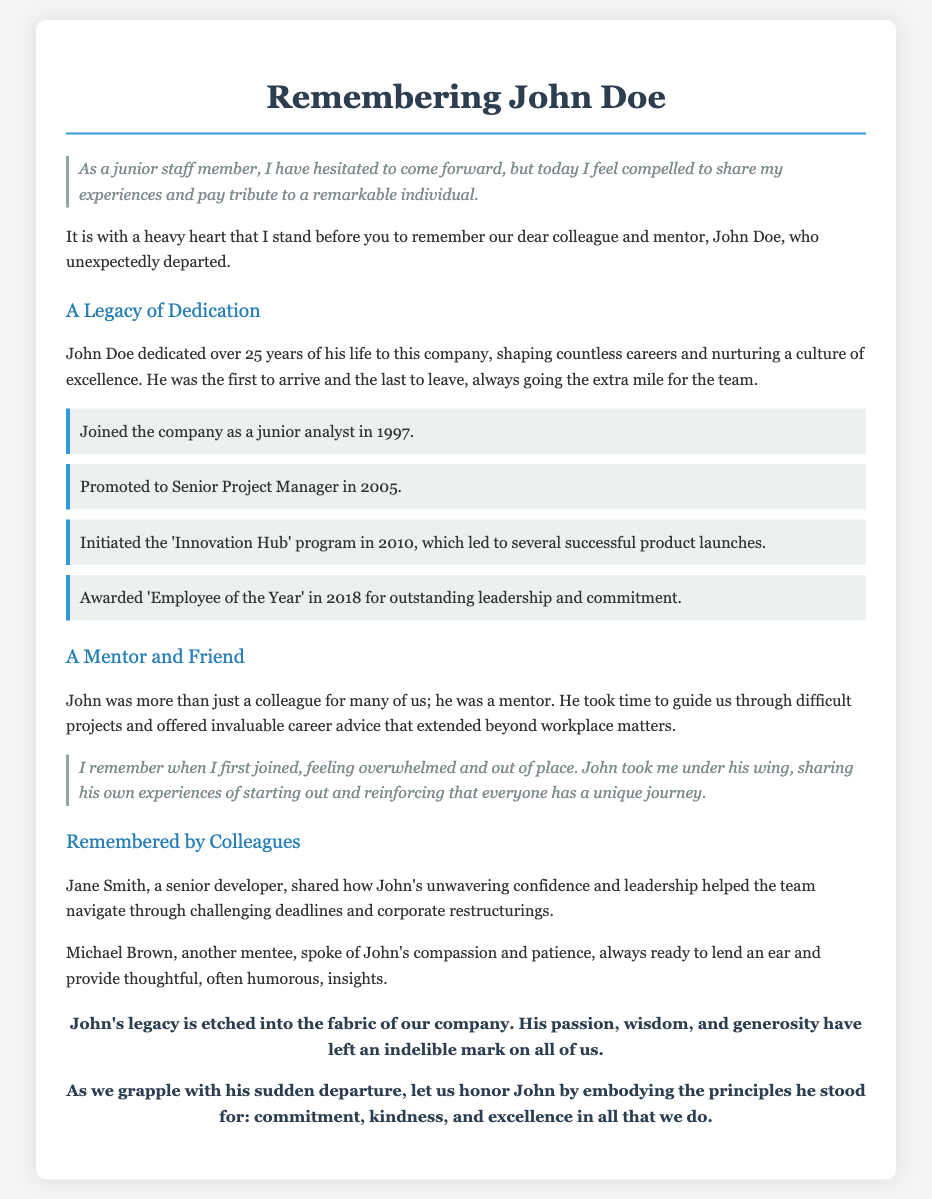What year did John Doe join the company? The document states that John Doe joined the company in 1997.
Answer: 1997 How many years did John dedicate to the company? The document mentions that John dedicated over 25 years of his life to the company.
Answer: 25 years What program did John initiate in 2010? The document lists that John initiated the 'Innovation Hub' program in 2010.
Answer: 'Innovation Hub' Who described John's leadership helping the team? The document quotes Jane Smith, a senior developer, about John's leadership.
Answer: Jane Smith What award did John receive in 2018? According to the document, John was awarded 'Employee of the Year' in 2018.
Answer: 'Employee of the Year' What role did John hold when he was promoted in 2005? The document states that John was promoted to Senior Project Manager in 2005.
Answer: Senior Project Manager What impact did John have on new employees? The document states that John took new employees under his wing, sharing his experiences.
Answer: Mentorship What quotation reflects the speaker's feelings about John? The document includes a quote stating, "As a junior staff member, I have hesitated to come forward."
Answer: "I have hesitated to come forward." What are the principles to honor John? The closing section mentions honoring John by embodying commitment, kindness, and excellence.
Answer: Commitment, kindness, and excellence 